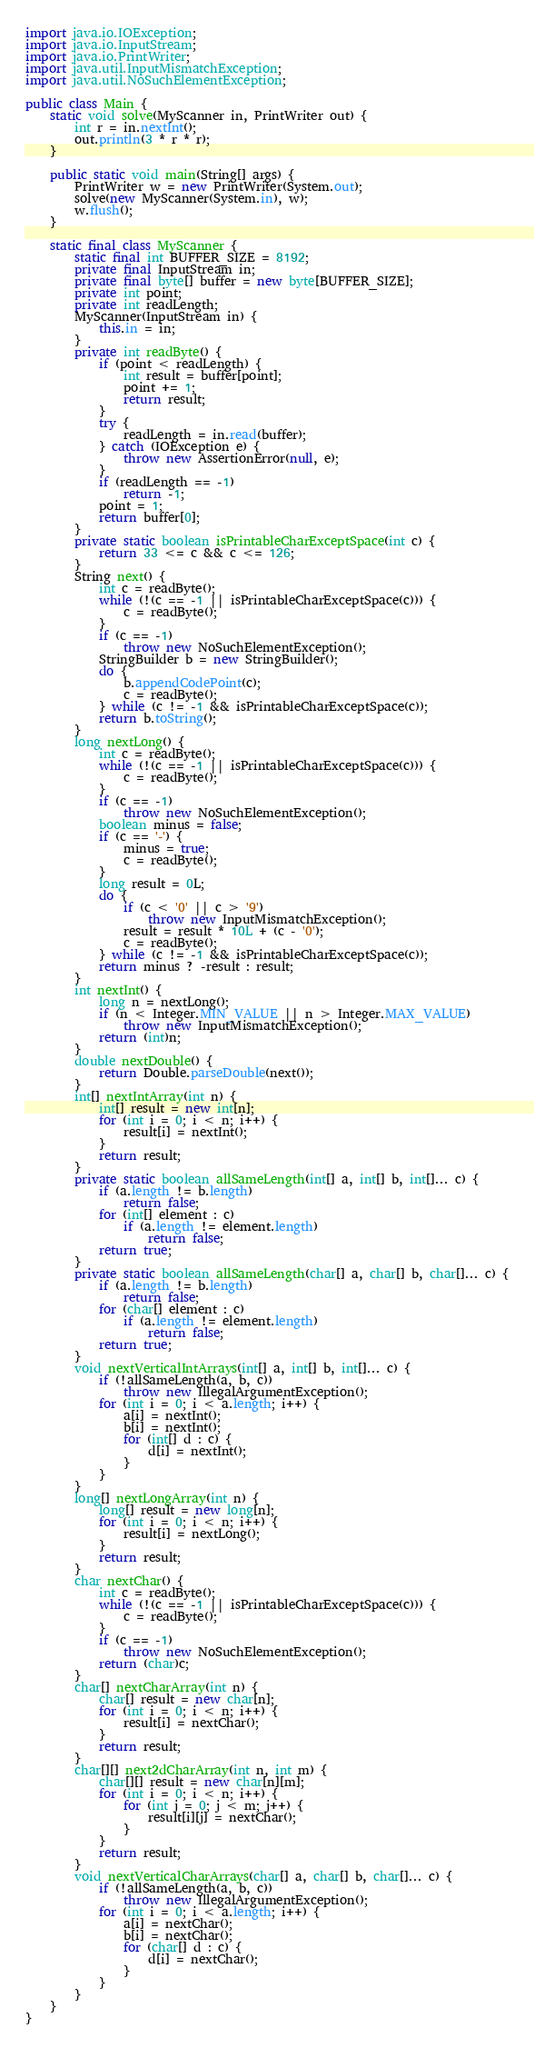Convert code to text. <code><loc_0><loc_0><loc_500><loc_500><_Java_>import java.io.IOException;
import java.io.InputStream;
import java.io.PrintWriter;
import java.util.InputMismatchException;
import java.util.NoSuchElementException;

public class Main {
    static void solve(MyScanner in, PrintWriter out) {
        int r = in.nextInt();
        out.println(3 * r * r);
    }

    public static void main(String[] args) {
        PrintWriter w = new PrintWriter(System.out);
        solve(new MyScanner(System.in), w);
        w.flush();
    }

    static final class MyScanner {
        static final int BUFFER_SIZE = 8192;
        private final InputStream in;
        private final byte[] buffer = new byte[BUFFER_SIZE];
        private int point;
        private int readLength;
        MyScanner(InputStream in) {
            this.in = in;
        }
        private int readByte() {
            if (point < readLength) {
                int result = buffer[point];
                point += 1;
                return result;
            }
            try {
                readLength = in.read(buffer);
            } catch (IOException e) {
                throw new AssertionError(null, e);
            }
            if (readLength == -1)
                return -1;
            point = 1;
            return buffer[0];
        }
        private static boolean isPrintableCharExceptSpace(int c) {
            return 33 <= c && c <= 126;
        }
        String next() {
            int c = readByte();
            while (!(c == -1 || isPrintableCharExceptSpace(c))) {
                c = readByte();
            }
            if (c == -1)
                throw new NoSuchElementException();
            StringBuilder b = new StringBuilder();
            do {
                b.appendCodePoint(c);
                c = readByte();
            } while (c != -1 && isPrintableCharExceptSpace(c));
            return b.toString();
        }
        long nextLong() {
            int c = readByte();
            while (!(c == -1 || isPrintableCharExceptSpace(c))) {
                c = readByte();
            }
            if (c == -1)
                throw new NoSuchElementException();
            boolean minus = false;
            if (c == '-') {
                minus = true;
                c = readByte();
            }
            long result = 0L;
            do {
                if (c < '0' || c > '9')
                    throw new InputMismatchException();
                result = result * 10L + (c - '0');
                c = readByte();
            } while (c != -1 && isPrintableCharExceptSpace(c));
            return minus ? -result : result;
        }
        int nextInt() {
            long n = nextLong();
            if (n < Integer.MIN_VALUE || n > Integer.MAX_VALUE)
                throw new InputMismatchException();
            return (int)n;
        }
        double nextDouble() {
            return Double.parseDouble(next());
        }
        int[] nextIntArray(int n) {
            int[] result = new int[n];
            for (int i = 0; i < n; i++) {
                result[i] = nextInt();
            }
            return result;
        }
        private static boolean allSameLength(int[] a, int[] b, int[]... c) {
            if (a.length != b.length)
                return false;
            for (int[] element : c)
                if (a.length != element.length)
                    return false;
            return true;
        }
        private static boolean allSameLength(char[] a, char[] b, char[]... c) {
            if (a.length != b.length)
                return false;
            for (char[] element : c)
                if (a.length != element.length)
                    return false;
            return true;
        }
        void nextVerticalIntArrays(int[] a, int[] b, int[]... c) {
            if (!allSameLength(a, b, c))
                throw new IllegalArgumentException();
            for (int i = 0; i < a.length; i++) {
                a[i] = nextInt();
                b[i] = nextInt();
                for (int[] d : c) {
                    d[i] = nextInt();
                }
            }
        }
        long[] nextLongArray(int n) {
            long[] result = new long[n];
            for (int i = 0; i < n; i++) {
                result[i] = nextLong();
            }
            return result;
        }
        char nextChar() {
            int c = readByte();
            while (!(c == -1 || isPrintableCharExceptSpace(c))) {
                c = readByte();
            }
            if (c == -1)
                throw new NoSuchElementException();
            return (char)c;
        }
        char[] nextCharArray(int n) {
            char[] result = new char[n];
            for (int i = 0; i < n; i++) {
                result[i] = nextChar();
            }
            return result;
        }
        char[][] next2dCharArray(int n, int m) {
            char[][] result = new char[n][m];
            for (int i = 0; i < n; i++) {
                for (int j = 0; j < m; j++) {
                    result[i][j] = nextChar();
                }
            }
            return result;
        }
        void nextVerticalCharArrays(char[] a, char[] b, char[]... c) {
            if (!allSameLength(a, b, c))
                throw new IllegalArgumentException();
            for (int i = 0; i < a.length; i++) {
                a[i] = nextChar();
                b[i] = nextChar();
                for (char[] d : c) {
                    d[i] = nextChar();
                }
            }
        }
    }
}
</code> 